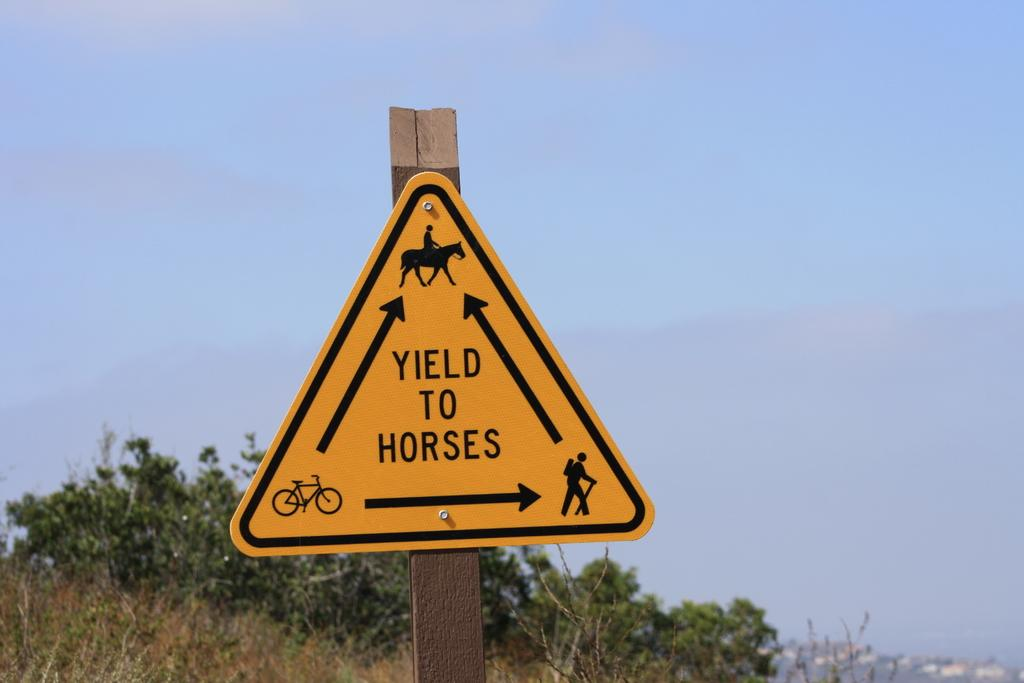<image>
Offer a succinct explanation of the picture presented. Yellow triangle sign on a post directing people to Yield To Horses. 